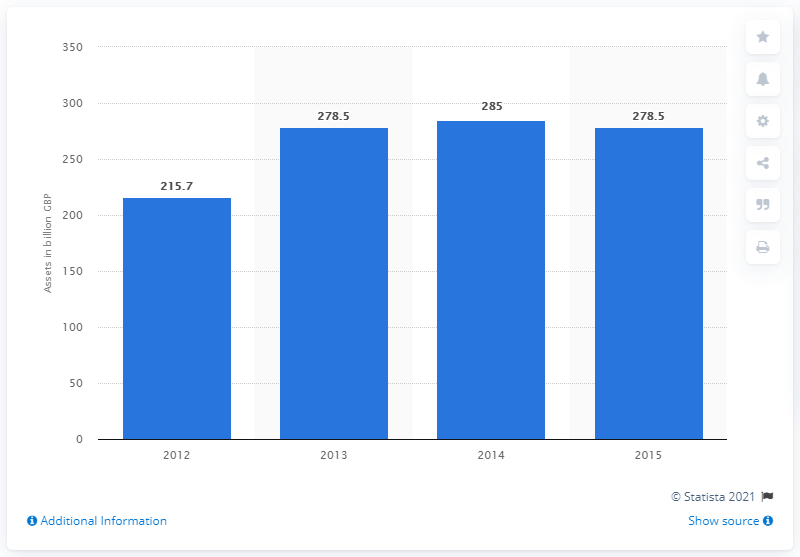Mention a couple of crucial points in this snapshot. At the end of 2014, the total assets under management were 285. 